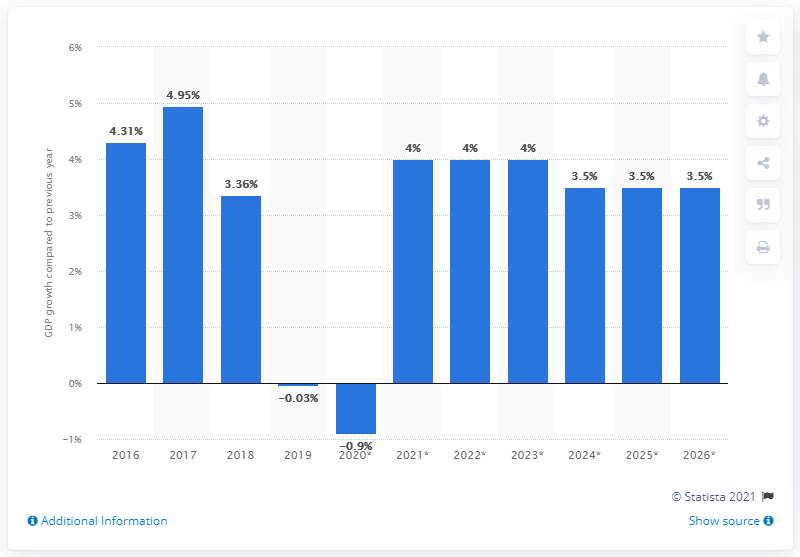Highlight a few significant elements in this photo. Paraguay's real GDP increased by 3.36% in 2018. 